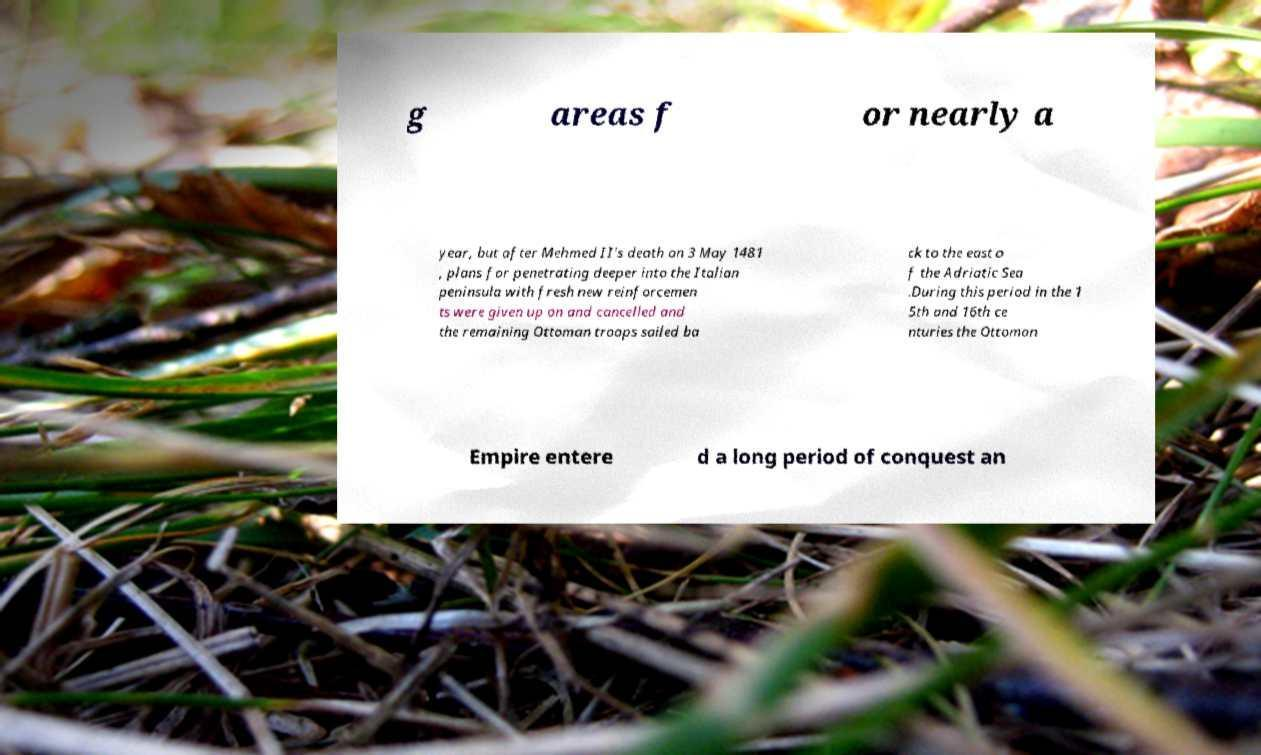Can you read and provide the text displayed in the image?This photo seems to have some interesting text. Can you extract and type it out for me? g areas f or nearly a year, but after Mehmed II's death on 3 May 1481 , plans for penetrating deeper into the Italian peninsula with fresh new reinforcemen ts were given up on and cancelled and the remaining Ottoman troops sailed ba ck to the east o f the Adriatic Sea .During this period in the 1 5th and 16th ce nturies the Ottoman Empire entere d a long period of conquest an 